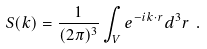<formula> <loc_0><loc_0><loc_500><loc_500>S ( { k } ) = \frac { 1 } { ( 2 \pi ) ^ { 3 } } \int _ { V } e ^ { - i { k } \cdot { r } } d ^ { 3 } r \ .</formula> 